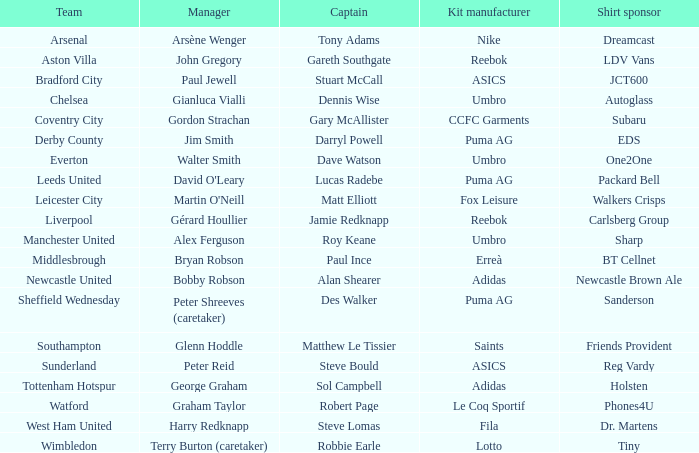Which shirt sponser has Nike as a kit manufacturer? Dreamcast. 